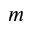<formula> <loc_0><loc_0><loc_500><loc_500>m</formula> 